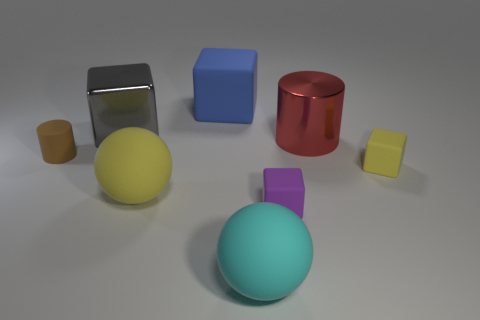What shape is the big red thing that is behind the tiny thing that is left of the blue matte object? The large red object positioned behind the small yellow object, to the left of the blue cube, is cylindrical in shape—resembling a typical can or barrel. 